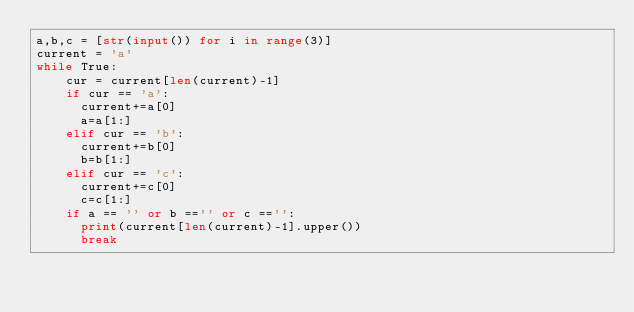Convert code to text. <code><loc_0><loc_0><loc_500><loc_500><_Python_>a,b,c = [str(input()) for i in range(3)]
current = 'a'
while True:
    cur = current[len(current)-1]
    if cur == 'a':
      current+=a[0]
      a=a[1:]
    elif cur == 'b':
      current+=b[0]
      b=b[1:]
    elif cur == 'c':
      current+=c[0]
      c=c[1:]
    if a == '' or b =='' or c =='':
      print(current[len(current)-1].upper())
      break</code> 